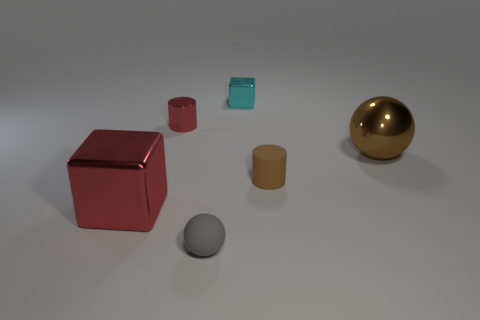How would you imagine these objects are used in real life? If these objects were real, they could represent a variety of uses. The cubes might be dice, storage containers, or artistic sculptures. The spheres could be decorative, like baubles or paperweights. The cylinder might be a canister or part of some mechanical system. 